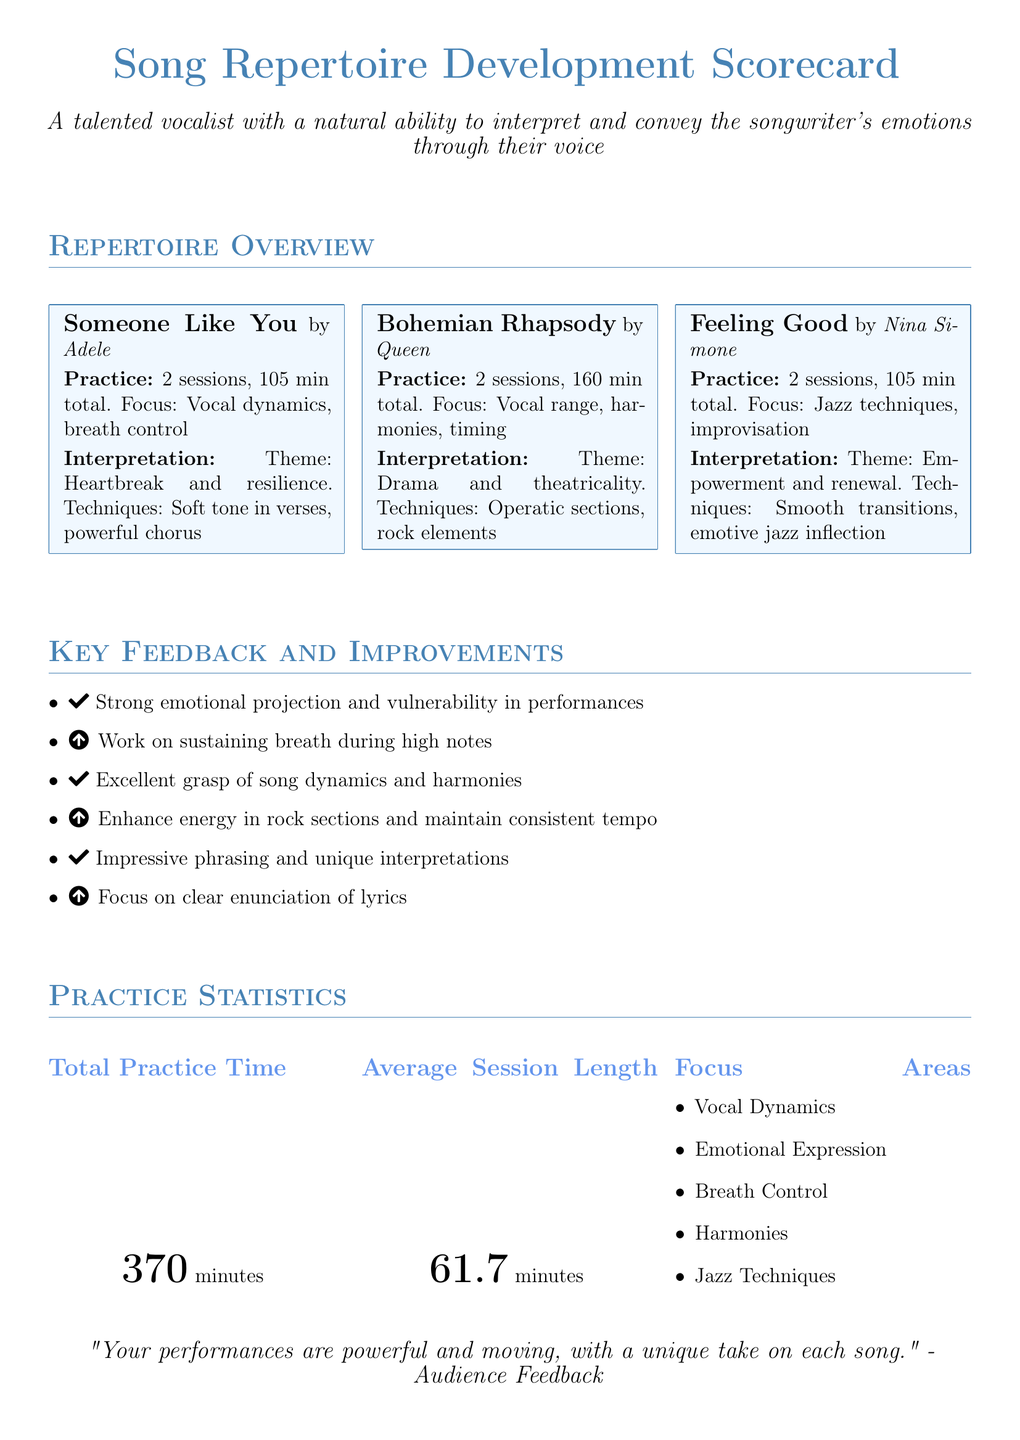What is the total practice time? The total practice time is mentioned in the "Practice Statistics" section, which specifies that it is 370 minutes.
Answer: 370 minutes How many sessions were logged for "Someone Like You"? The song "Someone Like You" has two practice sessions logged, as stated in its entry.
Answer: 2 sessions What is the focus for the song "Bohemian Rhapsody"? The focus for "Bohemian Rhapsody" is outlined in its entry, highlighting vocal range, harmonies, and timing.
Answer: Vocal range, harmonies, timing What is the average session length? The document states that the average session length is calculated in the "Practice Statistics" section, which reveals it is 61.7 minutes.
Answer: 61.7 minutes What theme is associated with the song "Feeling Good"? The theme for "Feeling Good" is stated in its entry, emphasizing empowerment and renewal.
Answer: Empowerment and renewal Which song has the technique of smooth transitions? The entry for "Feeling Good" indicates that one of its techniques is smooth transitions.
Answer: Feeling Good What improvement is suggested regarding breath? One item listed in the "Key Feedback and Improvements" section refers to the need to work on sustaining breath during high notes.
Answer: Sustaining breath during high notes What is the feedback regarding emotional projection? The document includes feedback that emphasizes strong emotional projection and vulnerability in performances.
Answer: Strong emotional projection What is one focus area listed in the "Practice Statistics"? The "Practice Statistics" section lists several focus areas; one of them is vocal dynamics.
Answer: Vocal Dynamics What song is associated with operatic elements? The entry for "Bohemian Rhapsody" describes its association with operatic sections as part of its techniques.
Answer: Bohemian Rhapsody 